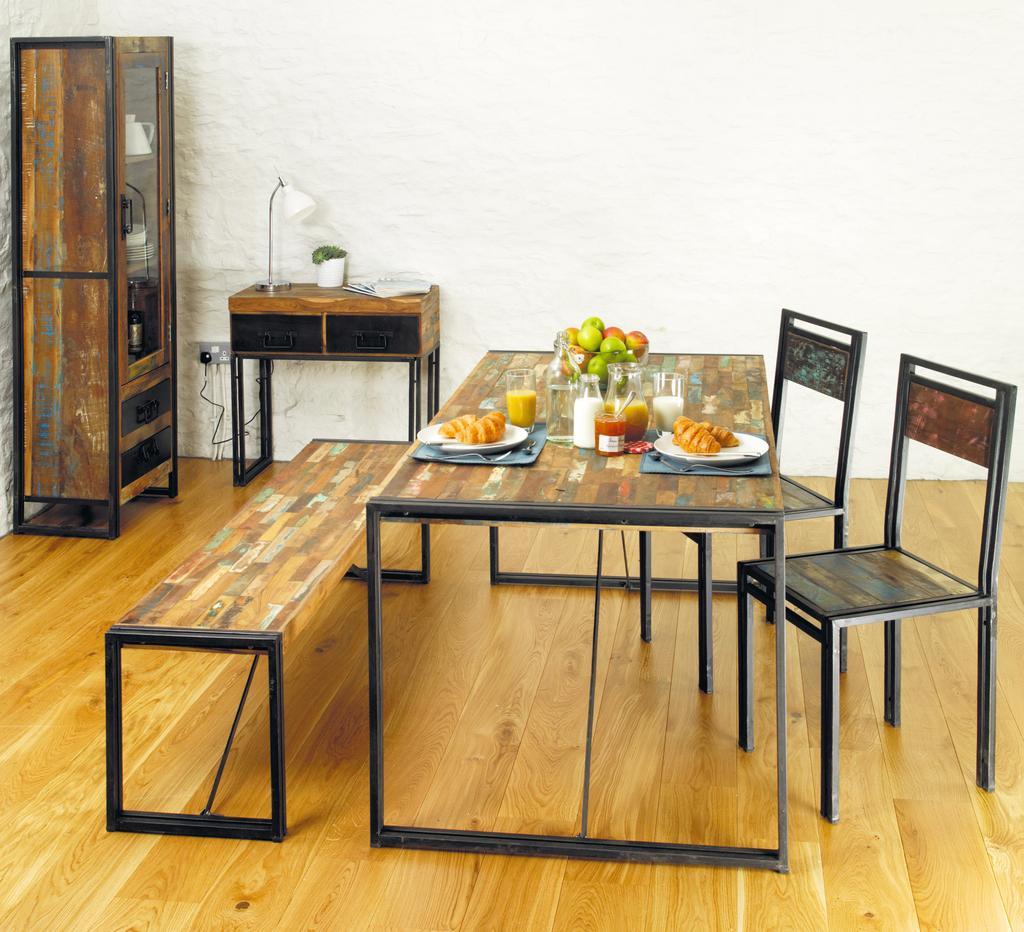How would you summarize this image in a sentence or two? In this image there is a table in the middle. On the table there are fruits,glasses and plates and some food stuff on the plates. There are two chairs on the right side and a bench on the left side. On the left side top there is a cupboard. Beside the cupboard there is a table on which there is a lamp and a jar. In the background there is a wall. 